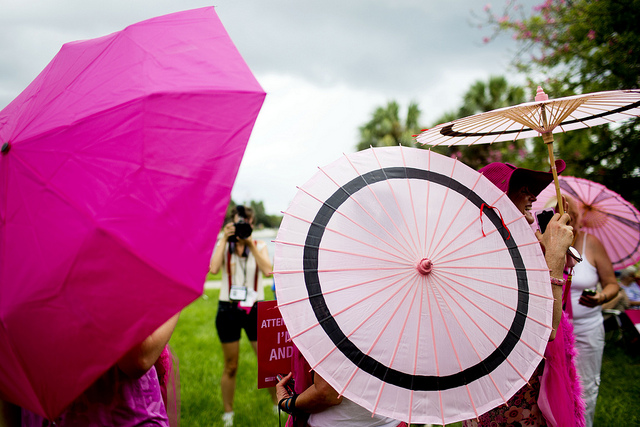Read all the text in this image. ATTEN I' AND 